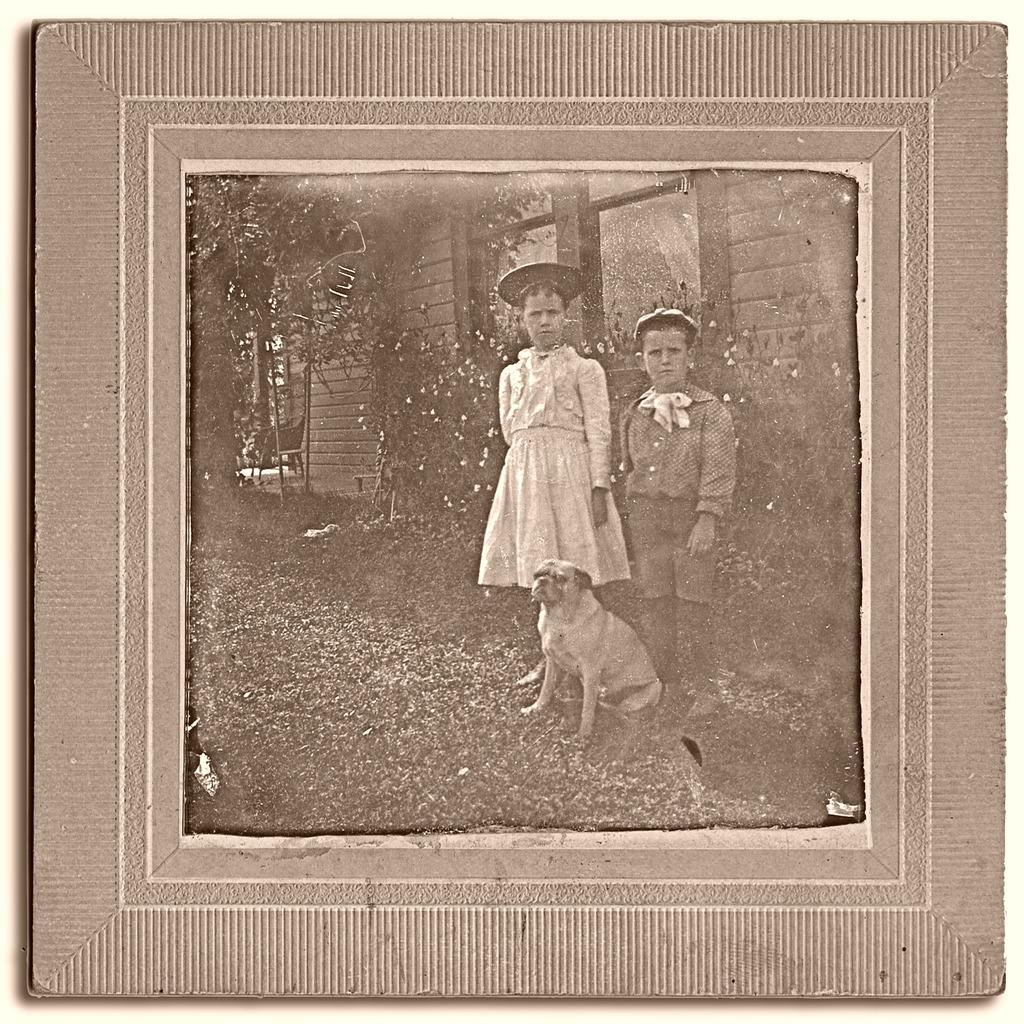What is inside the frame in the image? There is a photo with a frame in the image, and the photo contains a dog and two kids standing on a path. What can be seen behind the kids in the photo? There are trees behind the kids in the photo. What other objects are visible in the background of the photo? There is a chair and a house visible in the background of the photo. Can you hear the whistle of the dinosaurs in the image? There are no dinosaurs or whistles present in the image. 